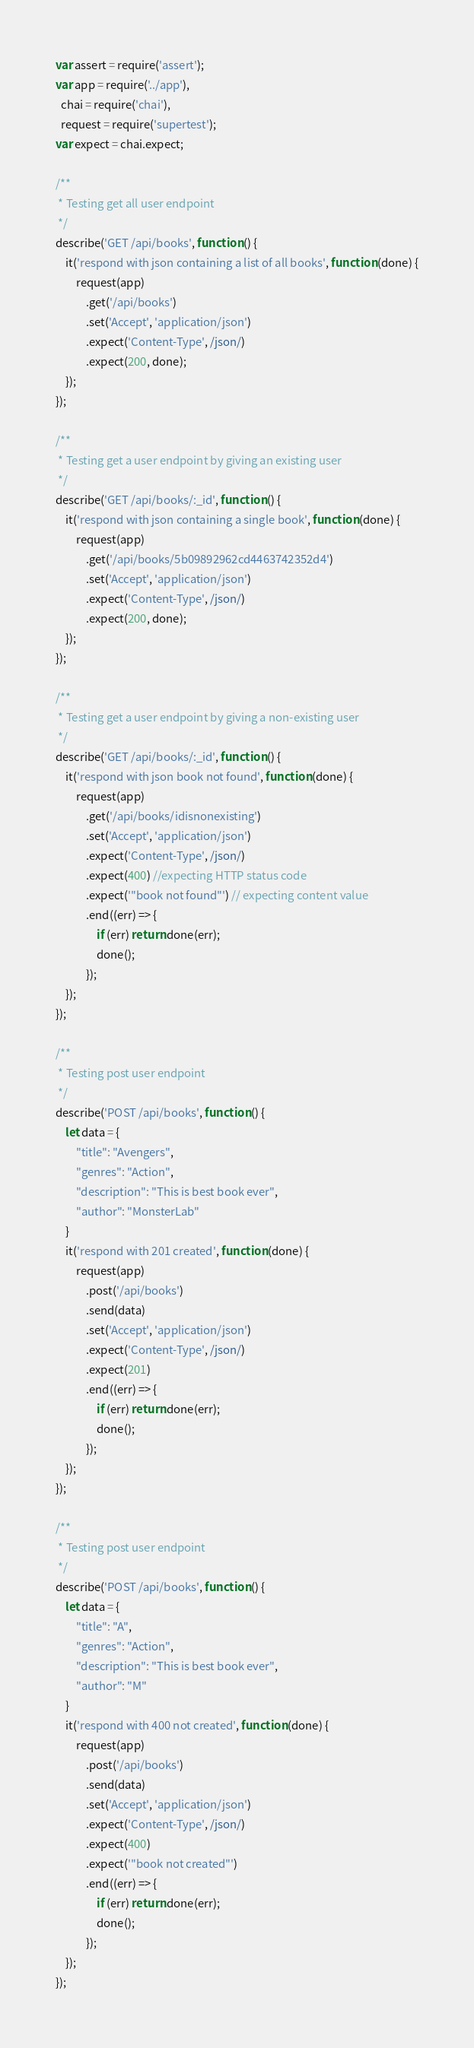Convert code to text. <code><loc_0><loc_0><loc_500><loc_500><_JavaScript_>var assert = require('assert');
var app = require('../app'),
  chai = require('chai'),
  request = require('supertest');
var expect = chai.expect;

/**
 * Testing get all user endpoint
 */
describe('GET /api/books', function () {
    it('respond with json containing a list of all books', function (done) {
        request(app)
            .get('/api/books')
            .set('Accept', 'application/json')
            .expect('Content-Type', /json/)
            .expect(200, done);
    });
});

/**
 * Testing get a user endpoint by giving an existing user
 */
describe('GET /api/books/:_id', function () {
    it('respond with json containing a single book', function (done) {
        request(app)
            .get('/api/books/5b09892962cd4463742352d4')
            .set('Accept', 'application/json')
            .expect('Content-Type', /json/)
            .expect(200, done);
    });
});

/**
 * Testing get a user endpoint by giving a non-existing user
 */
describe('GET /api/books/:_id', function () {
    it('respond with json book not found', function (done) {
        request(app)
            .get('/api/books/idisnonexisting')
            .set('Accept', 'application/json')
            .expect('Content-Type', /json/)
            .expect(400) //expecting HTTP status code
            .expect('"book not found"') // expecting content value
            .end((err) => {
                if (err) return done(err);
                done();
            });
    });
});

/**
 * Testing post user endpoint
 */
describe('POST /api/books', function () {
    let data = {
        "title": "Avengers",
        "genres": "Action",
        "description": "This is best book ever",
        "author": "MonsterLab"
    }
    it('respond with 201 created', function (done) {
        request(app)
            .post('/api/books')
            .send(data)
            .set('Accept', 'application/json')
            .expect('Content-Type', /json/)
            .expect(201)
            .end((err) => {
                if (err) return done(err);
                done();
            });
    });
});

/**
 * Testing post user endpoint
 */
describe('POST /api/books', function () {
    let data = {
        "title": "A",
        "genres": "Action",
        "description": "This is best book ever",
        "author": "M"
    }
    it('respond with 400 not created', function (done) {
        request(app)
            .post('/api/books')
            .send(data)
            .set('Accept', 'application/json')
            .expect('Content-Type', /json/)
            .expect(400)
            .expect('"book not created"')
            .end((err) => {
                if (err) return done(err);
                done();
            });
    });
});</code> 